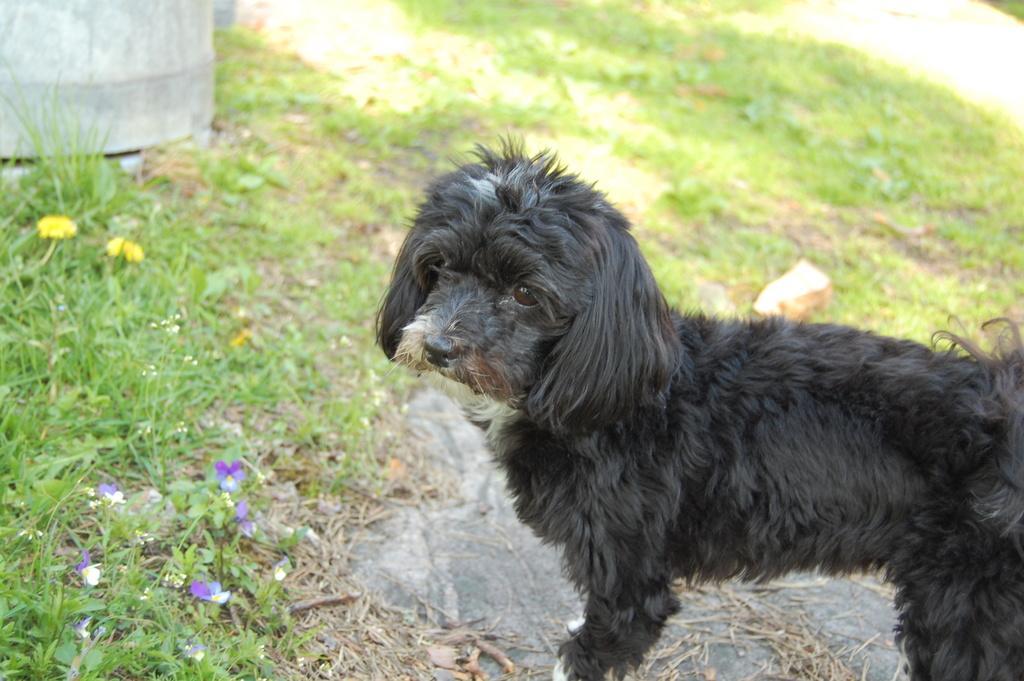Describe this image in one or two sentences. On the right side of the picture there is a dog. On the left side there are flowers, plants and grass. The background is blurred. In the background there is grass. It is a sunny day. 